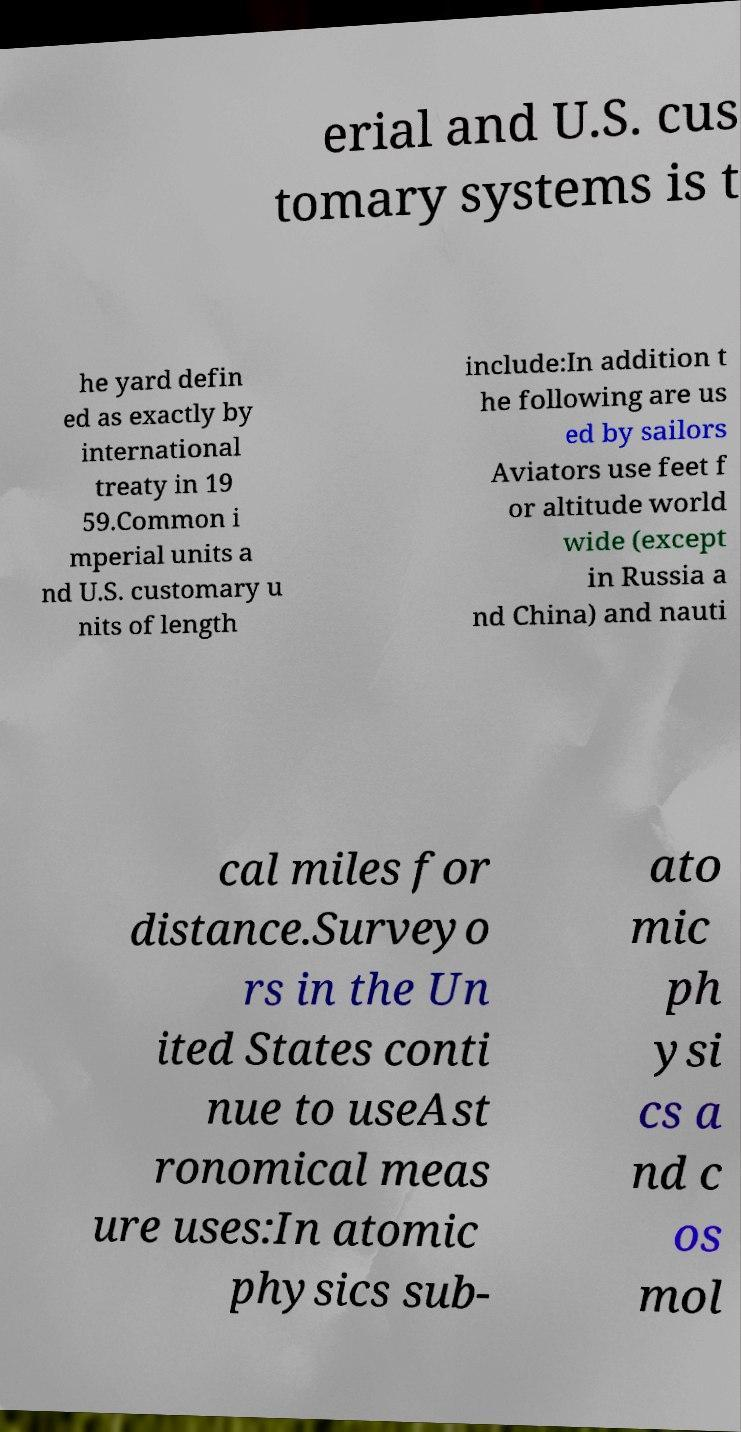Please read and relay the text visible in this image. What does it say? erial and U.S. cus tomary systems is t he yard defin ed as exactly by international treaty in 19 59.Common i mperial units a nd U.S. customary u nits of length include:In addition t he following are us ed by sailors Aviators use feet f or altitude world wide (except in Russia a nd China) and nauti cal miles for distance.Surveyo rs in the Un ited States conti nue to useAst ronomical meas ure uses:In atomic physics sub- ato mic ph ysi cs a nd c os mol 